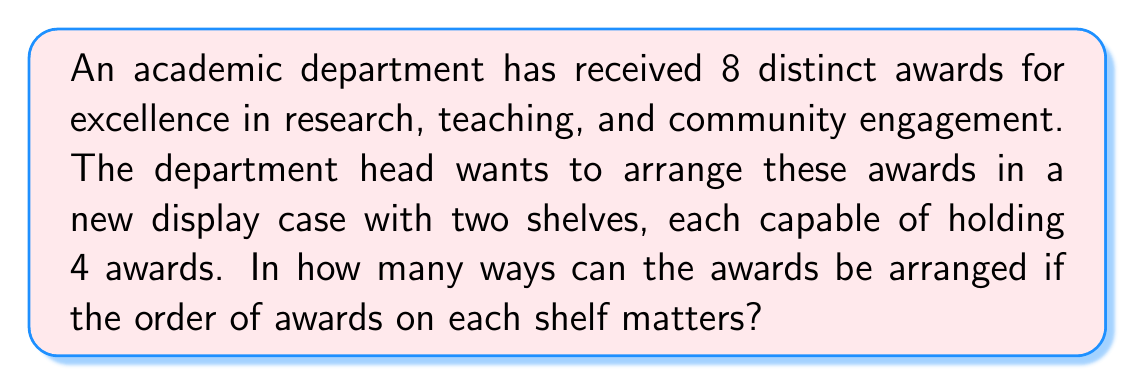Solve this math problem. Let's approach this step-by-step:

1) First, we need to choose which 4 awards will go on the top shelf. This can be done in $\binom{8}{4}$ ways.

2) $\binom{8}{4}$ can be calculated as:
   $$\binom{8}{4} = \frac{8!}{4!(8-4)!} = \frac{8!}{4!4!} = 70$$

3) Once we've selected 4 awards for the top shelf, the remaining 4 will automatically go on the bottom shelf.

4) Now, for each selection of awards on the shelves, we need to consider the arrangements on each shelf.

5) On the top shelf, we can arrange 4 awards in 4! = 24 ways.

6) Similarly, on the bottom shelf, we can arrange the other 4 awards in 4! = 24 ways.

7) By the multiplication principle, for each selection of awards, we have 24 * 24 = 576 possible arrangements.

8) Therefore, the total number of possible arrangements is:
   $$70 * 576 = 40,320$$

This calculation ensures that every possible selection and arrangement of the awards is counted, aligning with the department head's focus on showcasing academic excellence comprehensively.
Answer: 40,320 